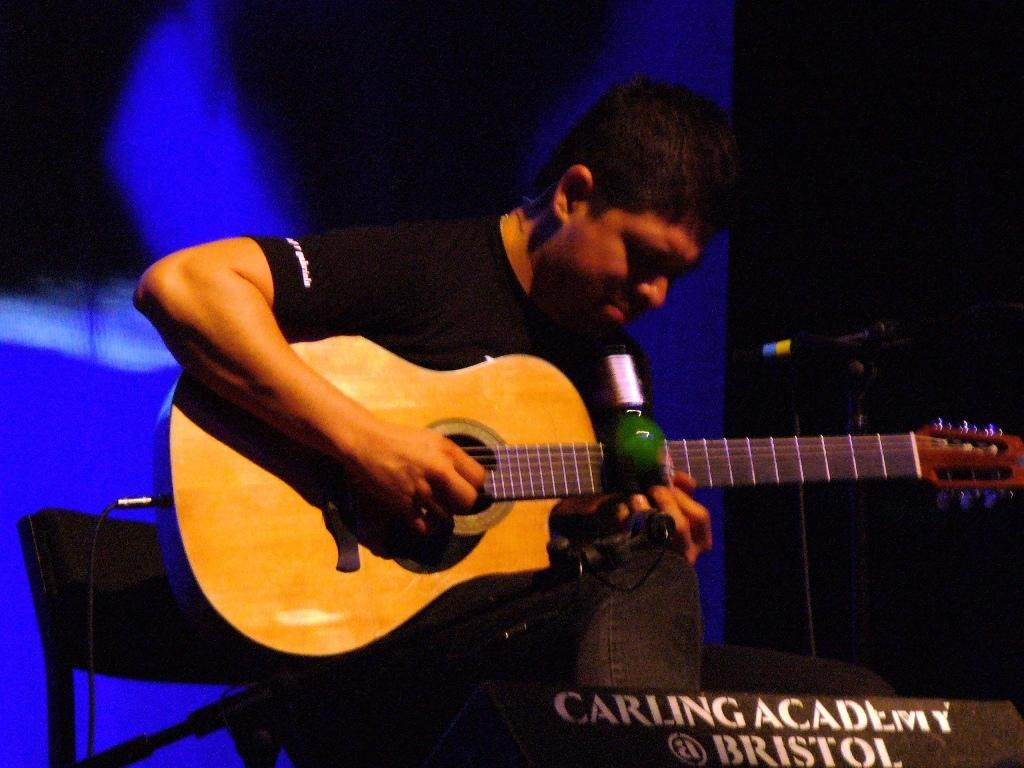What is the main subject of the image? There is a person in the image. What is the person wearing? The person is wearing a black color T-shirt. What activity is the person engaged in? The person is playing a guitar. What object is in front of the person? There is a microphone in front of the person. What type of muscle is being exercised by the person in the image? There is no indication of any muscle exercise in the image; the person is playing a guitar. 